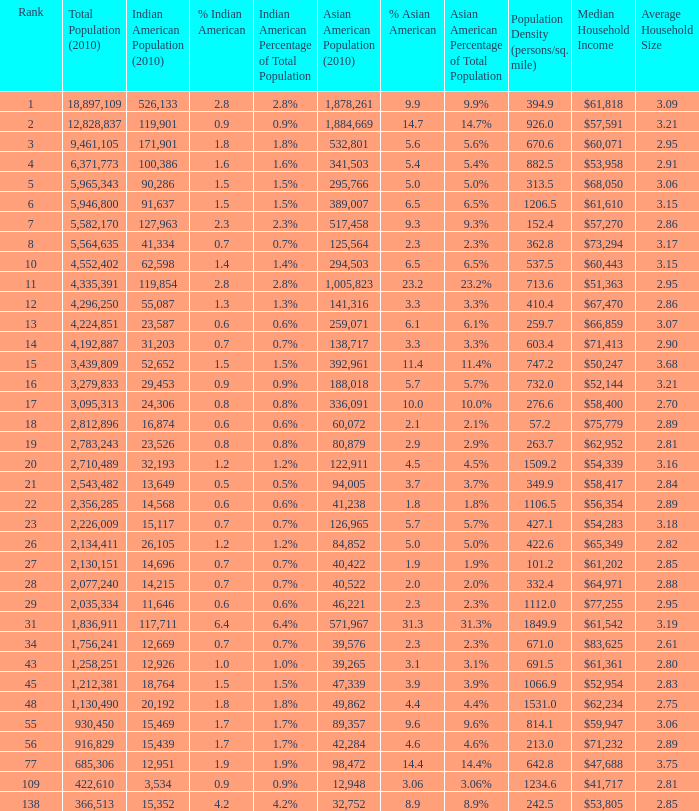What's the total population when the Asian American population is less than 60,072, the Indian American population is more than 14,696 and is 4.2% Indian American? 366513.0. Would you be able to parse every entry in this table? {'header': ['Rank', 'Total Population (2010)', 'Indian American Population (2010)', '% Indian American', 'Indian American Percentage of Total Population', 'Asian American Population (2010)', '% Asian American', 'Asian American Percentage of Total Population', 'Population Density (persons/sq. mile)', 'Median Household Income', 'Average Household Size'], 'rows': [['1', '18,897,109', '526,133', '2.8', '2.8%', '1,878,261', '9.9', '9.9%', '394.9', '$61,818', '3.09'], ['2', '12,828,837', '119,901', '0.9', '0.9%', '1,884,669', '14.7', '14.7%', '926.0', '$57,591', '3.21'], ['3', '9,461,105', '171,901', '1.8', '1.8%', '532,801', '5.6', '5.6%', '670.6', '$60,071', '2.95'], ['4', '6,371,773', '100,386', '1.6', '1.6%', '341,503', '5.4', '5.4%', '882.5', '$53,958', '2.91'], ['5', '5,965,343', '90,286', '1.5', '1.5%', '295,766', '5.0', '5.0%', '313.5', '$68,050', '3.06'], ['6', '5,946,800', '91,637', '1.5', '1.5%', '389,007', '6.5', '6.5%', '1206.5', '$61,610', '3.15'], ['7', '5,582,170', '127,963', '2.3', '2.3%', '517,458', '9.3', '9.3%', '152.4', '$57,270', '2.86'], ['8', '5,564,635', '41,334', '0.7', '0.7%', '125,564', '2.3', '2.3%', '362.8', '$73,294', '3.17'], ['10', '4,552,402', '62,598', '1.4', '1.4%', '294,503', '6.5', '6.5%', '537.5', '$60,443', '3.15'], ['11', '4,335,391', '119,854', '2.8', '2.8%', '1,005,823', '23.2', '23.2%', '713.6', '$51,363', '2.95'], ['12', '4,296,250', '55,087', '1.3', '1.3%', '141,316', '3.3', '3.3%', '410.4', '$67,470', '2.86'], ['13', '4,224,851', '23,587', '0.6', '0.6%', '259,071', '6.1', '6.1%', '259.7', '$66,859', '3.07'], ['14', '4,192,887', '31,203', '0.7', '0.7%', '138,717', '3.3', '3.3%', '603.4', '$71,413', '2.90'], ['15', '3,439,809', '52,652', '1.5', '1.5%', '392,961', '11.4', '11.4%', '747.2', '$50,247', '3.68'], ['16', '3,279,833', '29,453', '0.9', '0.9%', '188,018', '5.7', '5.7%', '732.0', '$52,144', '3.21'], ['17', '3,095,313', '24,306', '0.8', '0.8%', '336,091', '10.0', '10.0%', '276.6', '$58,400', '2.70'], ['18', '2,812,896', '16,874', '0.6', '0.6%', '60,072', '2.1', '2.1%', '57.2', '$75,779', '2.89'], ['19', '2,783,243', '23,526', '0.8', '0.8%', '80,879', '2.9', '2.9%', '263.7', '$62,952', '2.81'], ['20', '2,710,489', '32,193', '1.2', '1.2%', '122,911', '4.5', '4.5%', '1509.2', '$54,339', '3.16'], ['21', '2,543,482', '13,649', '0.5', '0.5%', '94,005', '3.7', '3.7%', '349.9', '$58,417', '2.84'], ['22', '2,356,285', '14,568', '0.6', '0.6%', '41,238', '1.8', '1.8%', '1106.5', '$56,354', '2.89'], ['23', '2,226,009', '15,117', '0.7', '0.7%', '126,965', '5.7', '5.7%', '427.1', '$54,283', '3.18'], ['26', '2,134,411', '26,105', '1.2', '1.2%', '84,852', '5.0', '5.0%', '422.6', '$65,349', '2.82'], ['27', '2,130,151', '14,696', '0.7', '0.7%', '40,422', '1.9', '1.9%', '101.2', '$61,202', '2.85'], ['28', '2,077,240', '14,215', '0.7', '0.7%', '40,522', '2.0', '2.0%', '332.4', '$64,971', '2.88'], ['29', '2,035,334', '11,646', '0.6', '0.6%', '46,221', '2.3', '2.3%', '1112.0', '$77,255', '2.95'], ['31', '1,836,911', '117,711', '6.4', '6.4%', '571,967', '31.3', '31.3%', '1849.9', '$61,542', '3.19'], ['34', '1,756,241', '12,669', '0.7', '0.7%', '39,576', '2.3', '2.3%', '671.0', '$83,625', '2.61'], ['43', '1,258,251', '12,926', '1.0', '1.0%', '39,265', '3.1', '3.1%', '691.5', '$61,361', '2.80'], ['45', '1,212,381', '18,764', '1.5', '1.5%', '47,339', '3.9', '3.9%', '1066.9', '$52,954', '2.83'], ['48', '1,130,490', '20,192', '1.8', '1.8%', '49,862', '4.4', '4.4%', '1531.0', '$62,234', '2.75'], ['55', '930,450', '15,469', '1.7', '1.7%', '89,357', '9.6', '9.6%', '814.1', '$59,947', '3.06'], ['56', '916,829', '15,439', '1.7', '1.7%', '42,284', '4.6', '4.6%', '213.0', '$71,232', '2.89'], ['77', '685,306', '12,951', '1.9', '1.9%', '98,472', '14.4', '14.4%', '642.8', '$47,688', '3.75'], ['109', '422,610', '3,534', '0.9', '0.9%', '12,948', '3.06', '3.06%', '1234.6', '$41,717', '2.81'], ['138', '366,513', '15,352', '4.2', '4.2%', '32,752', '8.9', '8.9%', '242.5', '$53,805', '2.85']]} 